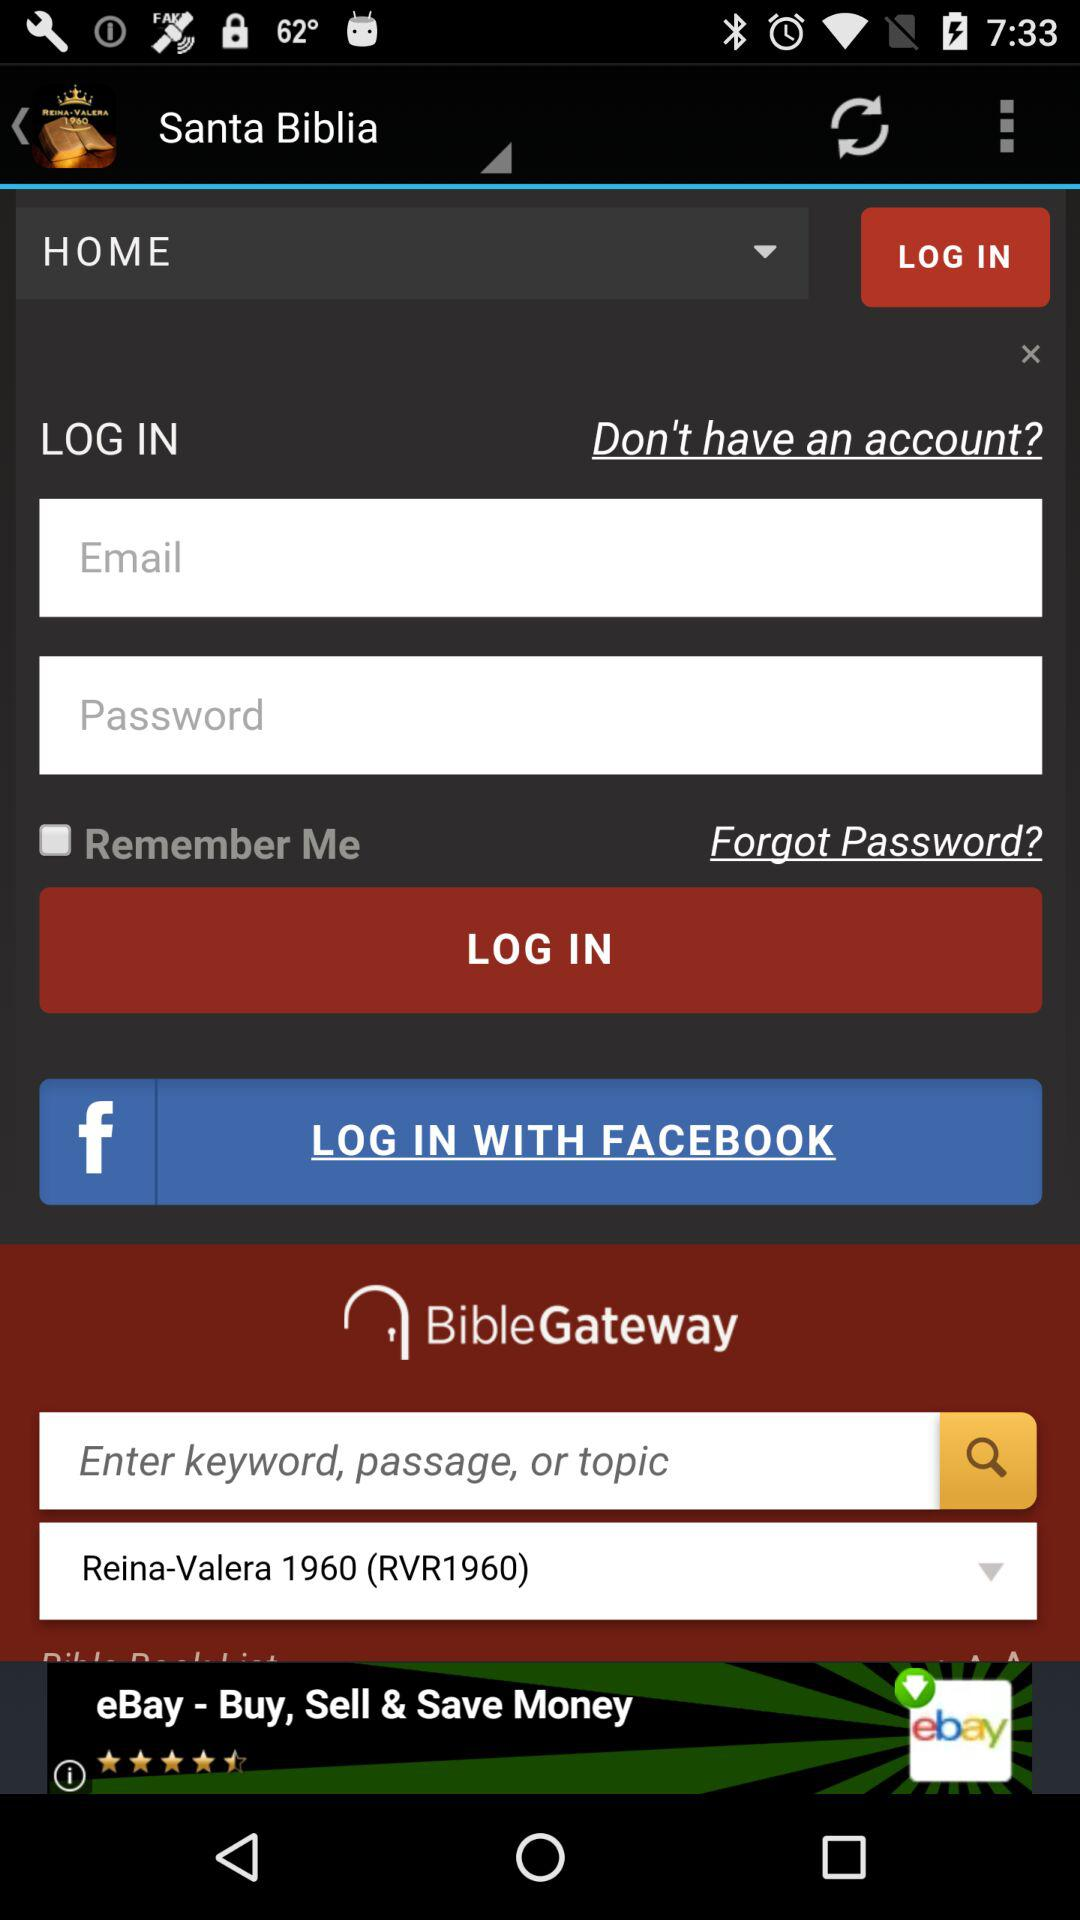What is the status of "Remember Me"? The status is "off". 